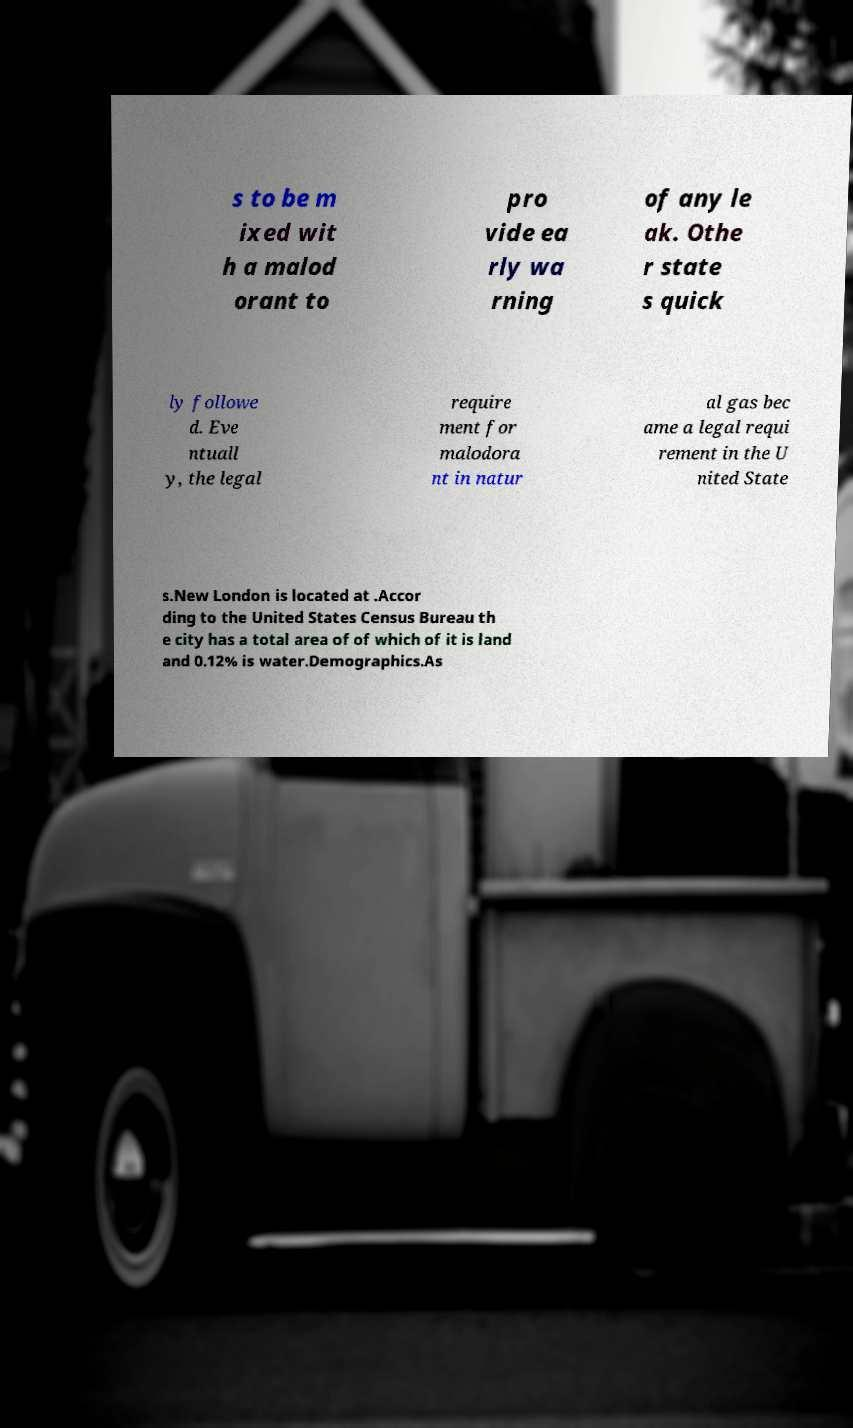For documentation purposes, I need the text within this image transcribed. Could you provide that? s to be m ixed wit h a malod orant to pro vide ea rly wa rning of any le ak. Othe r state s quick ly followe d. Eve ntuall y, the legal require ment for malodora nt in natur al gas bec ame a legal requi rement in the U nited State s.New London is located at .Accor ding to the United States Census Bureau th e city has a total area of of which of it is land and 0.12% is water.Demographics.As 